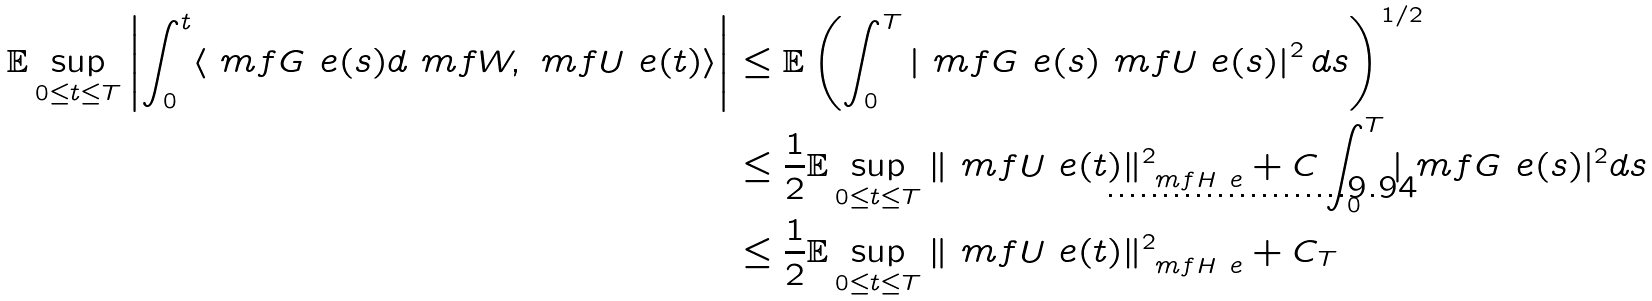<formula> <loc_0><loc_0><loc_500><loc_500>\mathbb { E } \sup _ { 0 \leq t \leq T } \left | \int _ { 0 } ^ { t } \langle \ m f { G } ^ { \ } e ( s ) d \ m f { W } , \ m f { U } ^ { \ } e ( t ) \rangle \right | & \leq \mathbb { E } \left ( \int _ { 0 } ^ { T } \left | \ m f { G } ^ { \ } e ( s ) \ m f { U } ^ { \ } e ( s ) \right | ^ { 2 } d s \right ) ^ { 1 / 2 } \\ & \leq \frac { 1 } { 2 } \mathbb { E } \sup _ { 0 \leq t \leq T } \| \ m f { U } ^ { \ } e ( t ) \| _ { \ m f { H } ^ { \ } e } ^ { 2 } + C \int _ { 0 } ^ { T } | \ m f { G } ^ { \ } e ( s ) | ^ { 2 } d s \\ & \leq \frac { 1 } { 2 } \mathbb { E } \sup _ { 0 \leq t \leq T } \| \ m f { U } ^ { \ } e ( t ) \| _ { \ m f { H } ^ { \ } e } ^ { 2 } + C _ { T }</formula> 